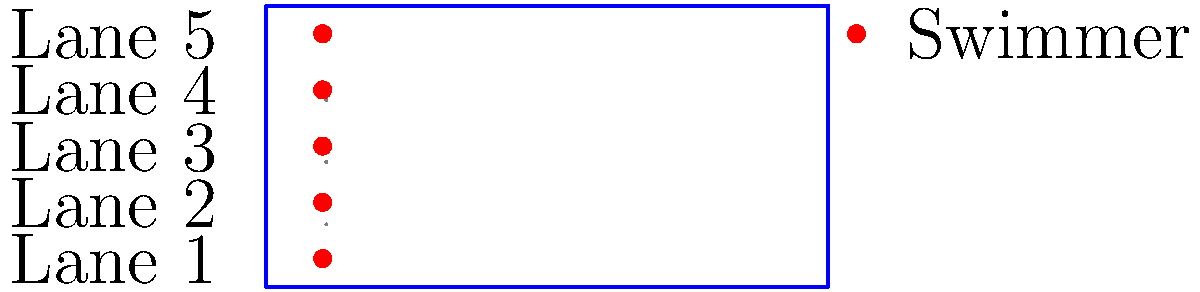As a competitive swimmer, you're tasked with determining the optimal lane assignment for a 50-meter freestyle race. Given the pool layout shown, where all lanes are equally spaced and waves from adjacent lanes can affect a swimmer's performance, which lane would you choose to maximize your chances of winning? Assume that the outer lanes (1 and 5) experience less turbulence from one side but more wall resistance. To determine the optimal lane assignment, we need to consider several factors:

1. Wave interference: Swimmers in the middle lanes (2, 3, and 4) experience waves from both sides, while those in the outer lanes (1 and 5) only have waves from one side.

2. Wall resistance: Lanes 1 and 5 are closer to the walls, which can create additional drag due to water rebounding off the walls.

3. Visibility: Middle lanes offer better visibility of competitors, which can be advantageous for pacing and strategy.

4. Psychological factors: Some swimmers prefer certain lanes due to personal preference or superstition.

Considering these factors:

1. Lanes 1 and 5 have less wave interference but more wall resistance.
2. Lanes 2 and 4 have a balance of wave interference and minimal wall effects.
3. Lane 3 has the most wave interference but the best visibility of all competitors.

For a 50-meter freestyle race, where speed is crucial and the race is short, the reduced wave interference in lanes 2 and 4 likely outweighs the slight advantage of better visibility in lane 3.

Between lanes 2 and 4, lane 4 is often preferred because it's further from the starting blocks, potentially reducing noise interference at the start.

Therefore, the optimal lane for maximizing chances of winning would be Lane 4.
Answer: Lane 4 